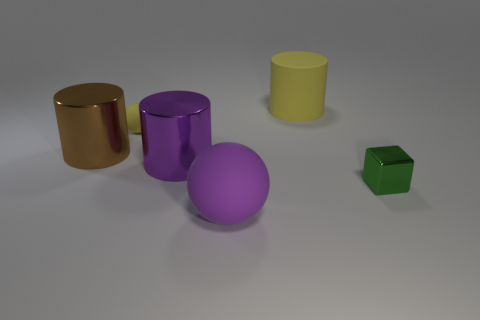What shape is the purple matte object?
Ensure brevity in your answer.  Sphere. There is a tiny object that is on the left side of the small block; is it the same shape as the object that is right of the big yellow matte object?
Keep it short and to the point. No. How many objects are either tiny gray spheres or things that are behind the green object?
Provide a succinct answer. 4. What is the thing that is both to the right of the purple metallic object and behind the shiny block made of?
Your answer should be compact. Rubber. Are there any other things that are the same shape as the small green thing?
Keep it short and to the point. No. The cylinder that is the same material as the tiny sphere is what color?
Offer a very short reply. Yellow. How many objects are big cyan metal cubes or big yellow things?
Your answer should be compact. 1. There is a purple metallic cylinder; is its size the same as the green shiny cube that is in front of the large brown metallic cylinder?
Provide a succinct answer. No. What is the color of the cylinder that is behind the yellow thing left of the yellow thing that is right of the small rubber ball?
Provide a succinct answer. Yellow. The block has what color?
Ensure brevity in your answer.  Green. 